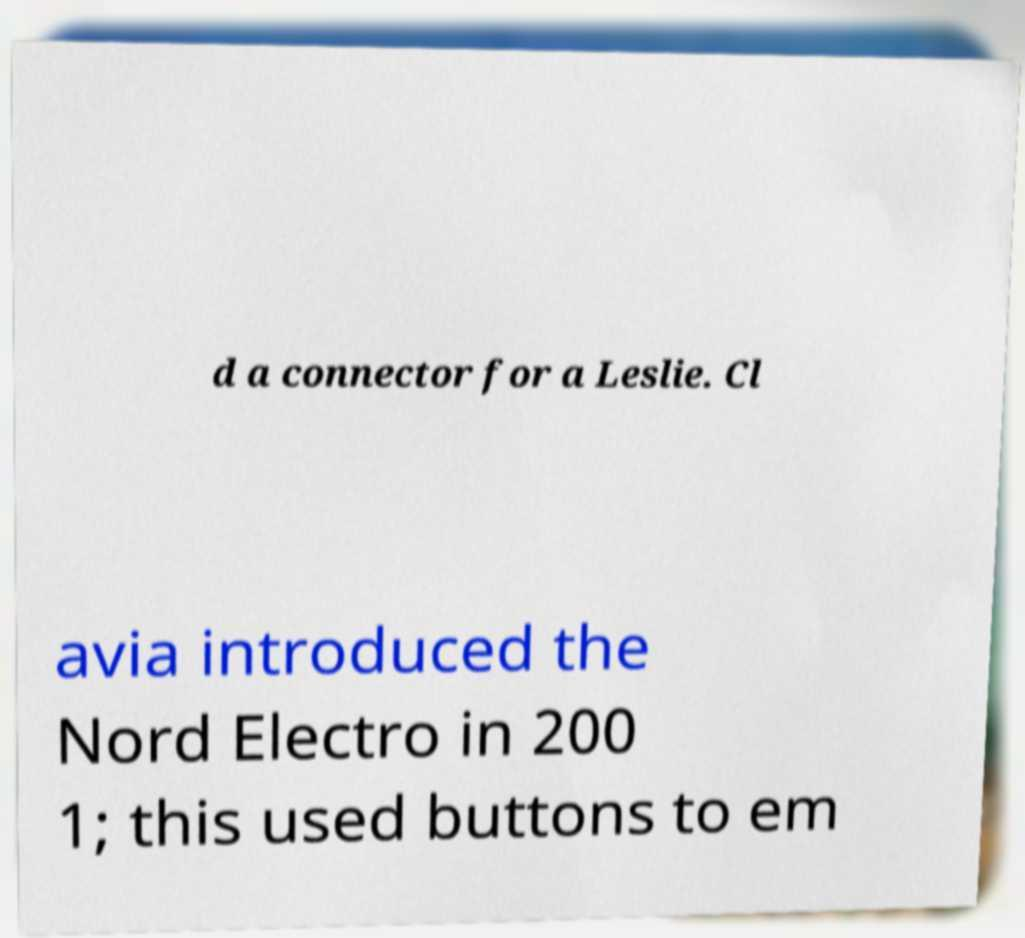Please identify and transcribe the text found in this image. d a connector for a Leslie. Cl avia introduced the Nord Electro in 200 1; this used buttons to em 